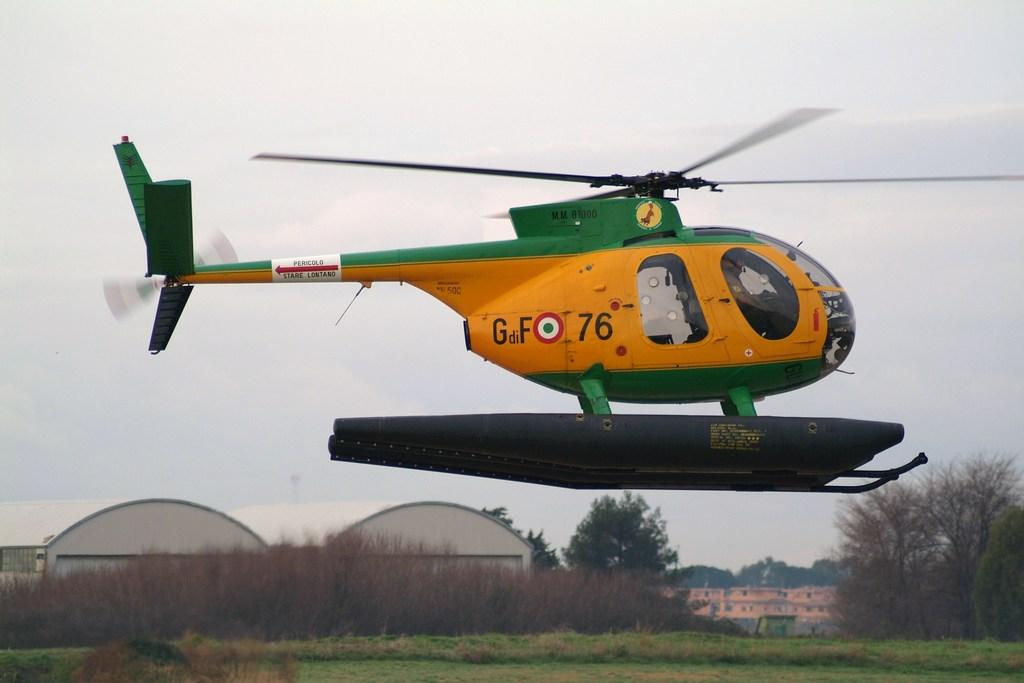What is the main subject of the image? There is a helicopter in the image. What can be seen in the background of the image? There are buildings, sheds, and trees in the background of the image. What is visible at the bottom of the image? The ground is visible at the bottom of the image. Can you see a stream flowing near the helicopter in the image? There is no stream visible in the image; it only features a helicopter, buildings, sheds, trees, and the ground. 